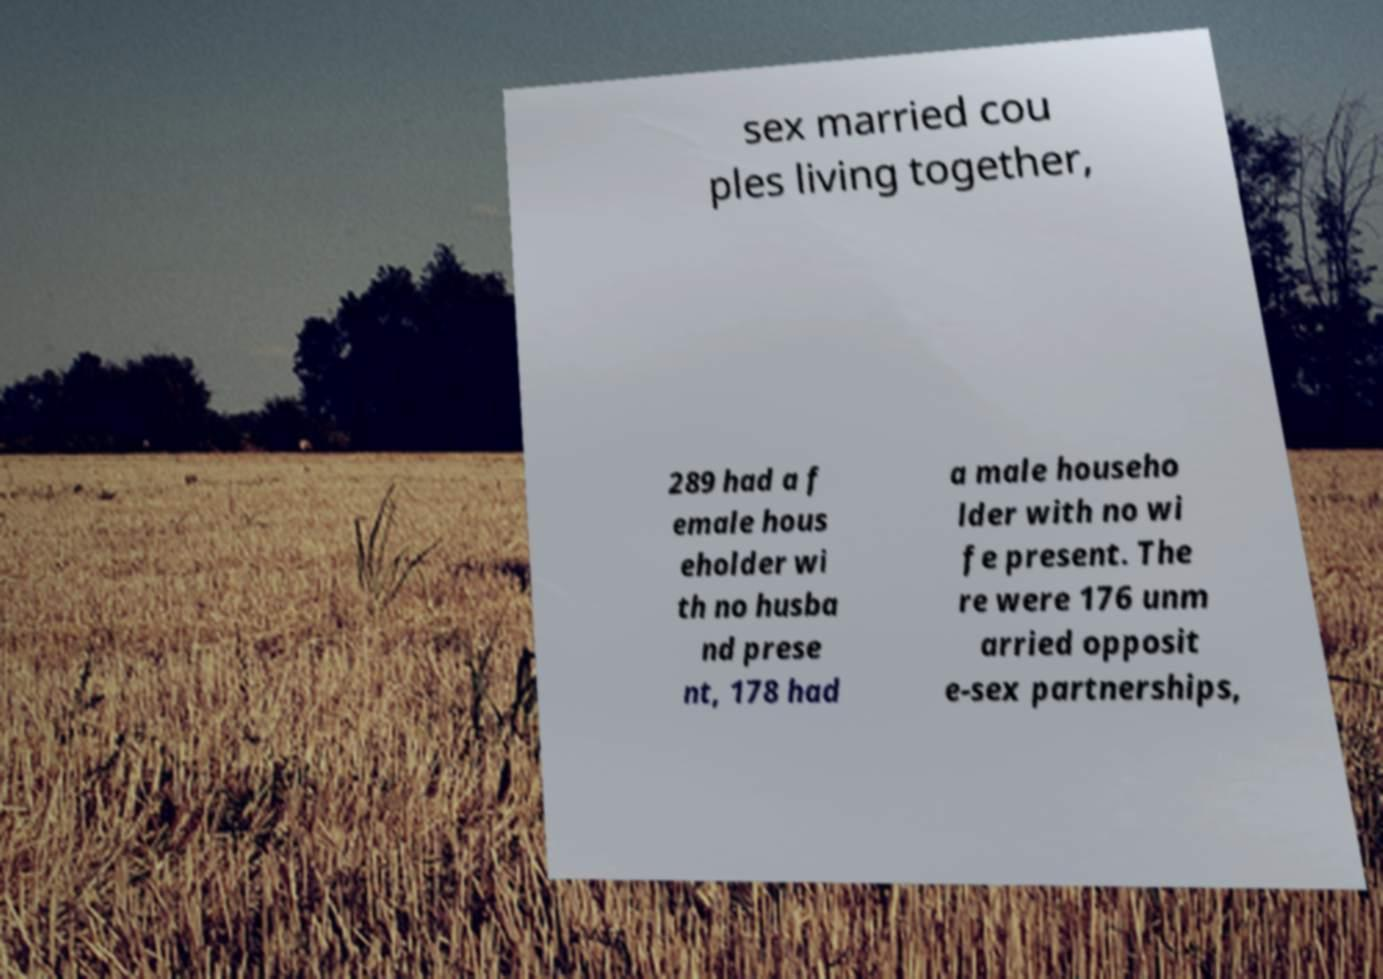Can you read and provide the text displayed in the image?This photo seems to have some interesting text. Can you extract and type it out for me? sex married cou ples living together, 289 had a f emale hous eholder wi th no husba nd prese nt, 178 had a male househo lder with no wi fe present. The re were 176 unm arried opposit e-sex partnerships, 